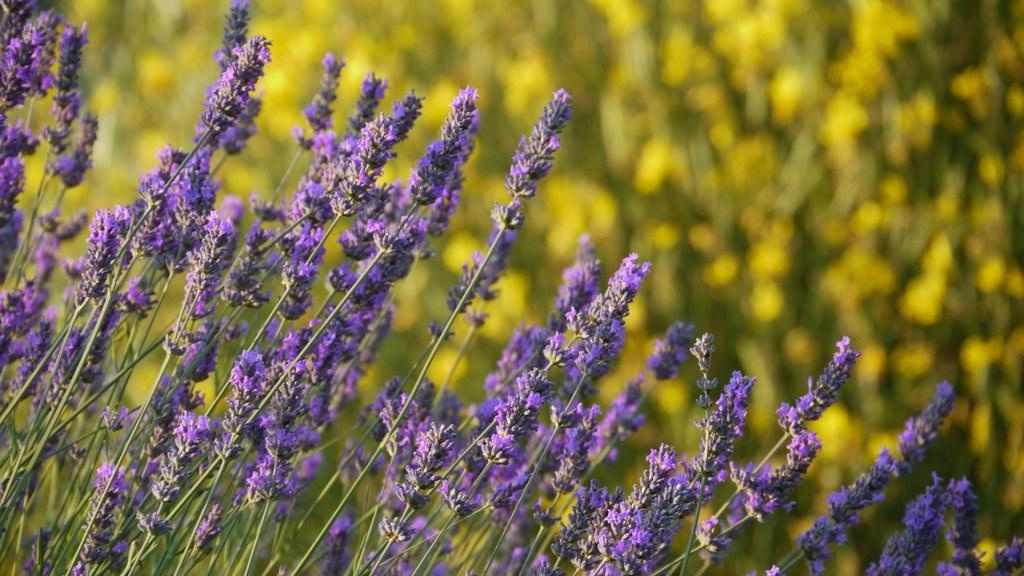Where was the image taken? The image was taken outdoors. What can be seen in the background of the image? There are plants in the background of the image. What type of plants are in the middle of the image? There are plants with lavender flowers in the middle of the image. What color are the lavender flowers? The lavender flowers are purple in color. How many beds are visible in the image? There are no beds present in the image. What type of sink can be seen in the background of the image? There is no sink visible in the image; it features plants and lavender flowers. 